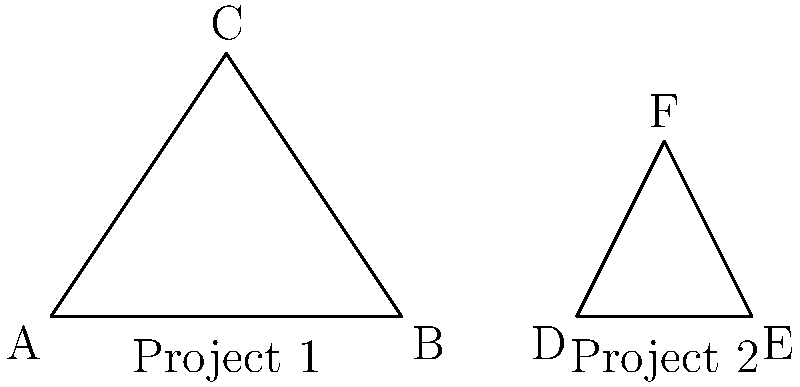In your role as a project manager implementing GIS solutions, you notice that two client projects have similar requirements represented by congruent triangles ABC and DEF. If the base of triangle ABC (side AB) is 4 units long and the height of triangle DEF is 2 units, what is the area of triangle ABC? Let's approach this step-by-step:

1) First, we know that triangles ABC and DEF are congruent, which means they have the same shape and size.

2) We're given that the base of triangle ABC (side AB) is 4 units long.

3) We're also given that the height of triangle DEF is 2 units.

4) Since the triangles are congruent, the height of triangle ABC must also be 2 units.

5) The formula for the area of a triangle is:

   $$A = \frac{1}{2} \times base \times height$$

6) Substituting our known values:

   $$A = \frac{1}{2} \times 4 \times 2$$

7) Simplifying:

   $$A = 4$$

Therefore, the area of triangle ABC is 4 square units.
Answer: 4 square units 